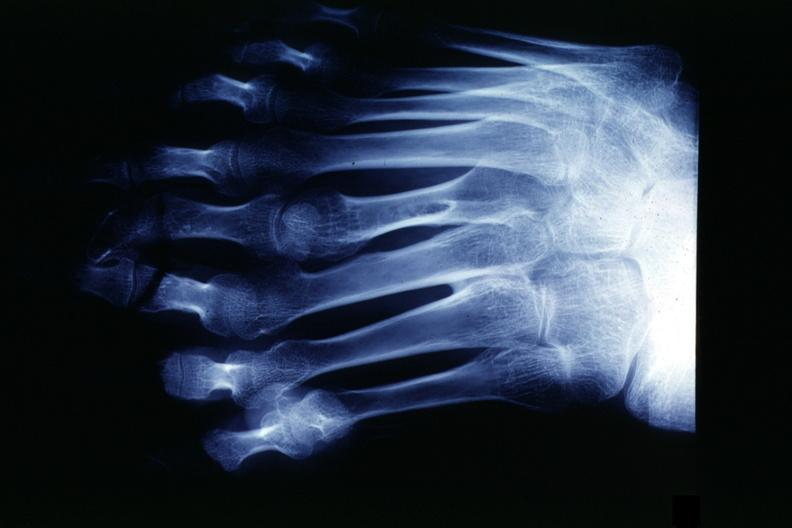re extremities present?
Answer the question using a single word or phrase. Yes 